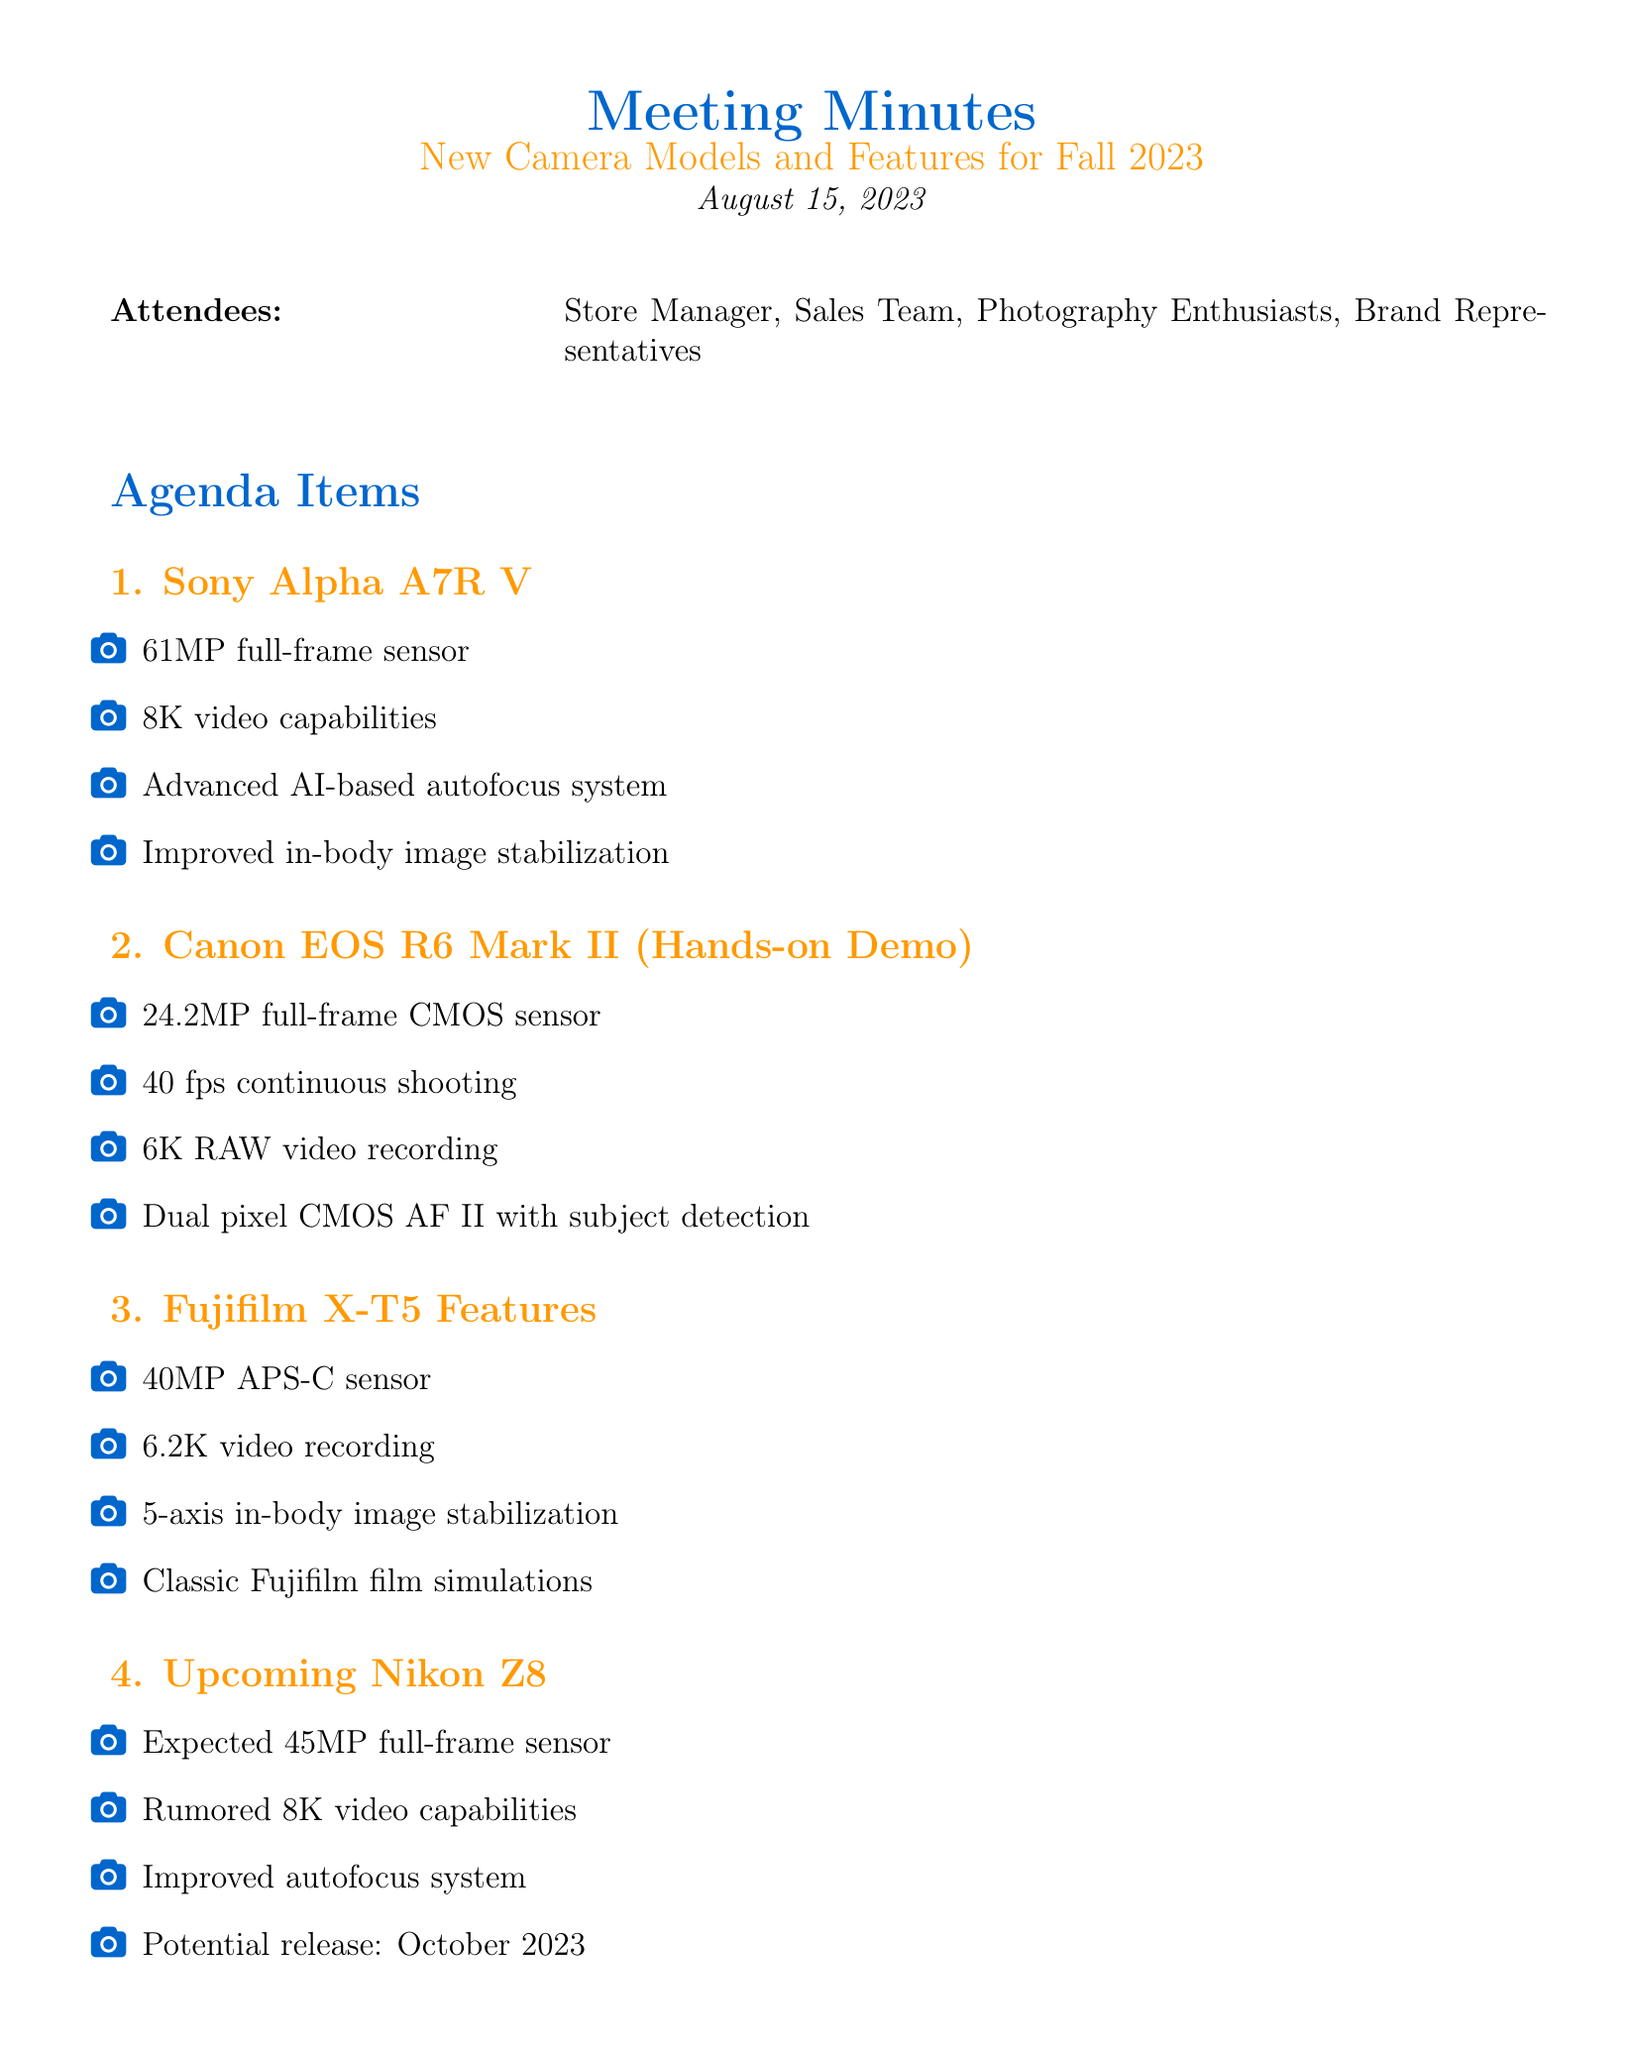What is the date of the meeting? The date of the meeting is stated in the document as August 15, 2023.
Answer: August 15, 2023 Who introduced the Sony Alpha A7R V? The document lists the attendees, but it does not specify who introduced the camera. Therefore, it cannot be answered from the document.
Answer: Not specified What is the resolution of the Canon EOS R6 Mark II? The resolution mentioned in the document for the Canon EOS R6 Mark II is 24.2MP.
Answer: 24.2MP What new feature does the Fujifilm X-T5 offer? The document lists several features, one of which is classic Fujifilm film simulations.
Answer: Classic Fujifilm film simulations What is the expected release month for the Nikon Z8? The document mentions a potential release date for the Nikon Z8 as October 2023.
Answer: October 2023 What action item involves customer engagement? The document outlines an action item to plan a customer workshop on new camera technologies.
Answer: Plan customer workshop on utilizing new camera technologies How many attendees were listed in the meeting? The document states four groups of attendees were present at the meeting: Store Manager, Sales Team, Photography Enthusiasts, Brand Representatives.
Answer: Four groups What is mentioned regarding low-light performance? The document includes improvements in low-light performance as part of emerging camera technologies.
Answer: Improvements in low-light performance 